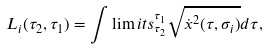<formula> <loc_0><loc_0><loc_500><loc_500>L _ { i } ( \tau _ { 2 } , \tau _ { 1 } ) = \int \lim i t s _ { \tau _ { 2 } } ^ { \tau _ { 1 } } \sqrt { \dot { x } ^ { 2 } ( \tau , \sigma _ { i } ) } d \tau ,</formula> 